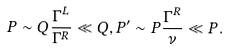Convert formula to latex. <formula><loc_0><loc_0><loc_500><loc_500>P \sim Q \frac { \Gamma ^ { L } } { \Gamma ^ { R } } \ll Q , P ^ { \prime } \sim P \frac { \Gamma ^ { R } } { \nu } \ll P .</formula> 